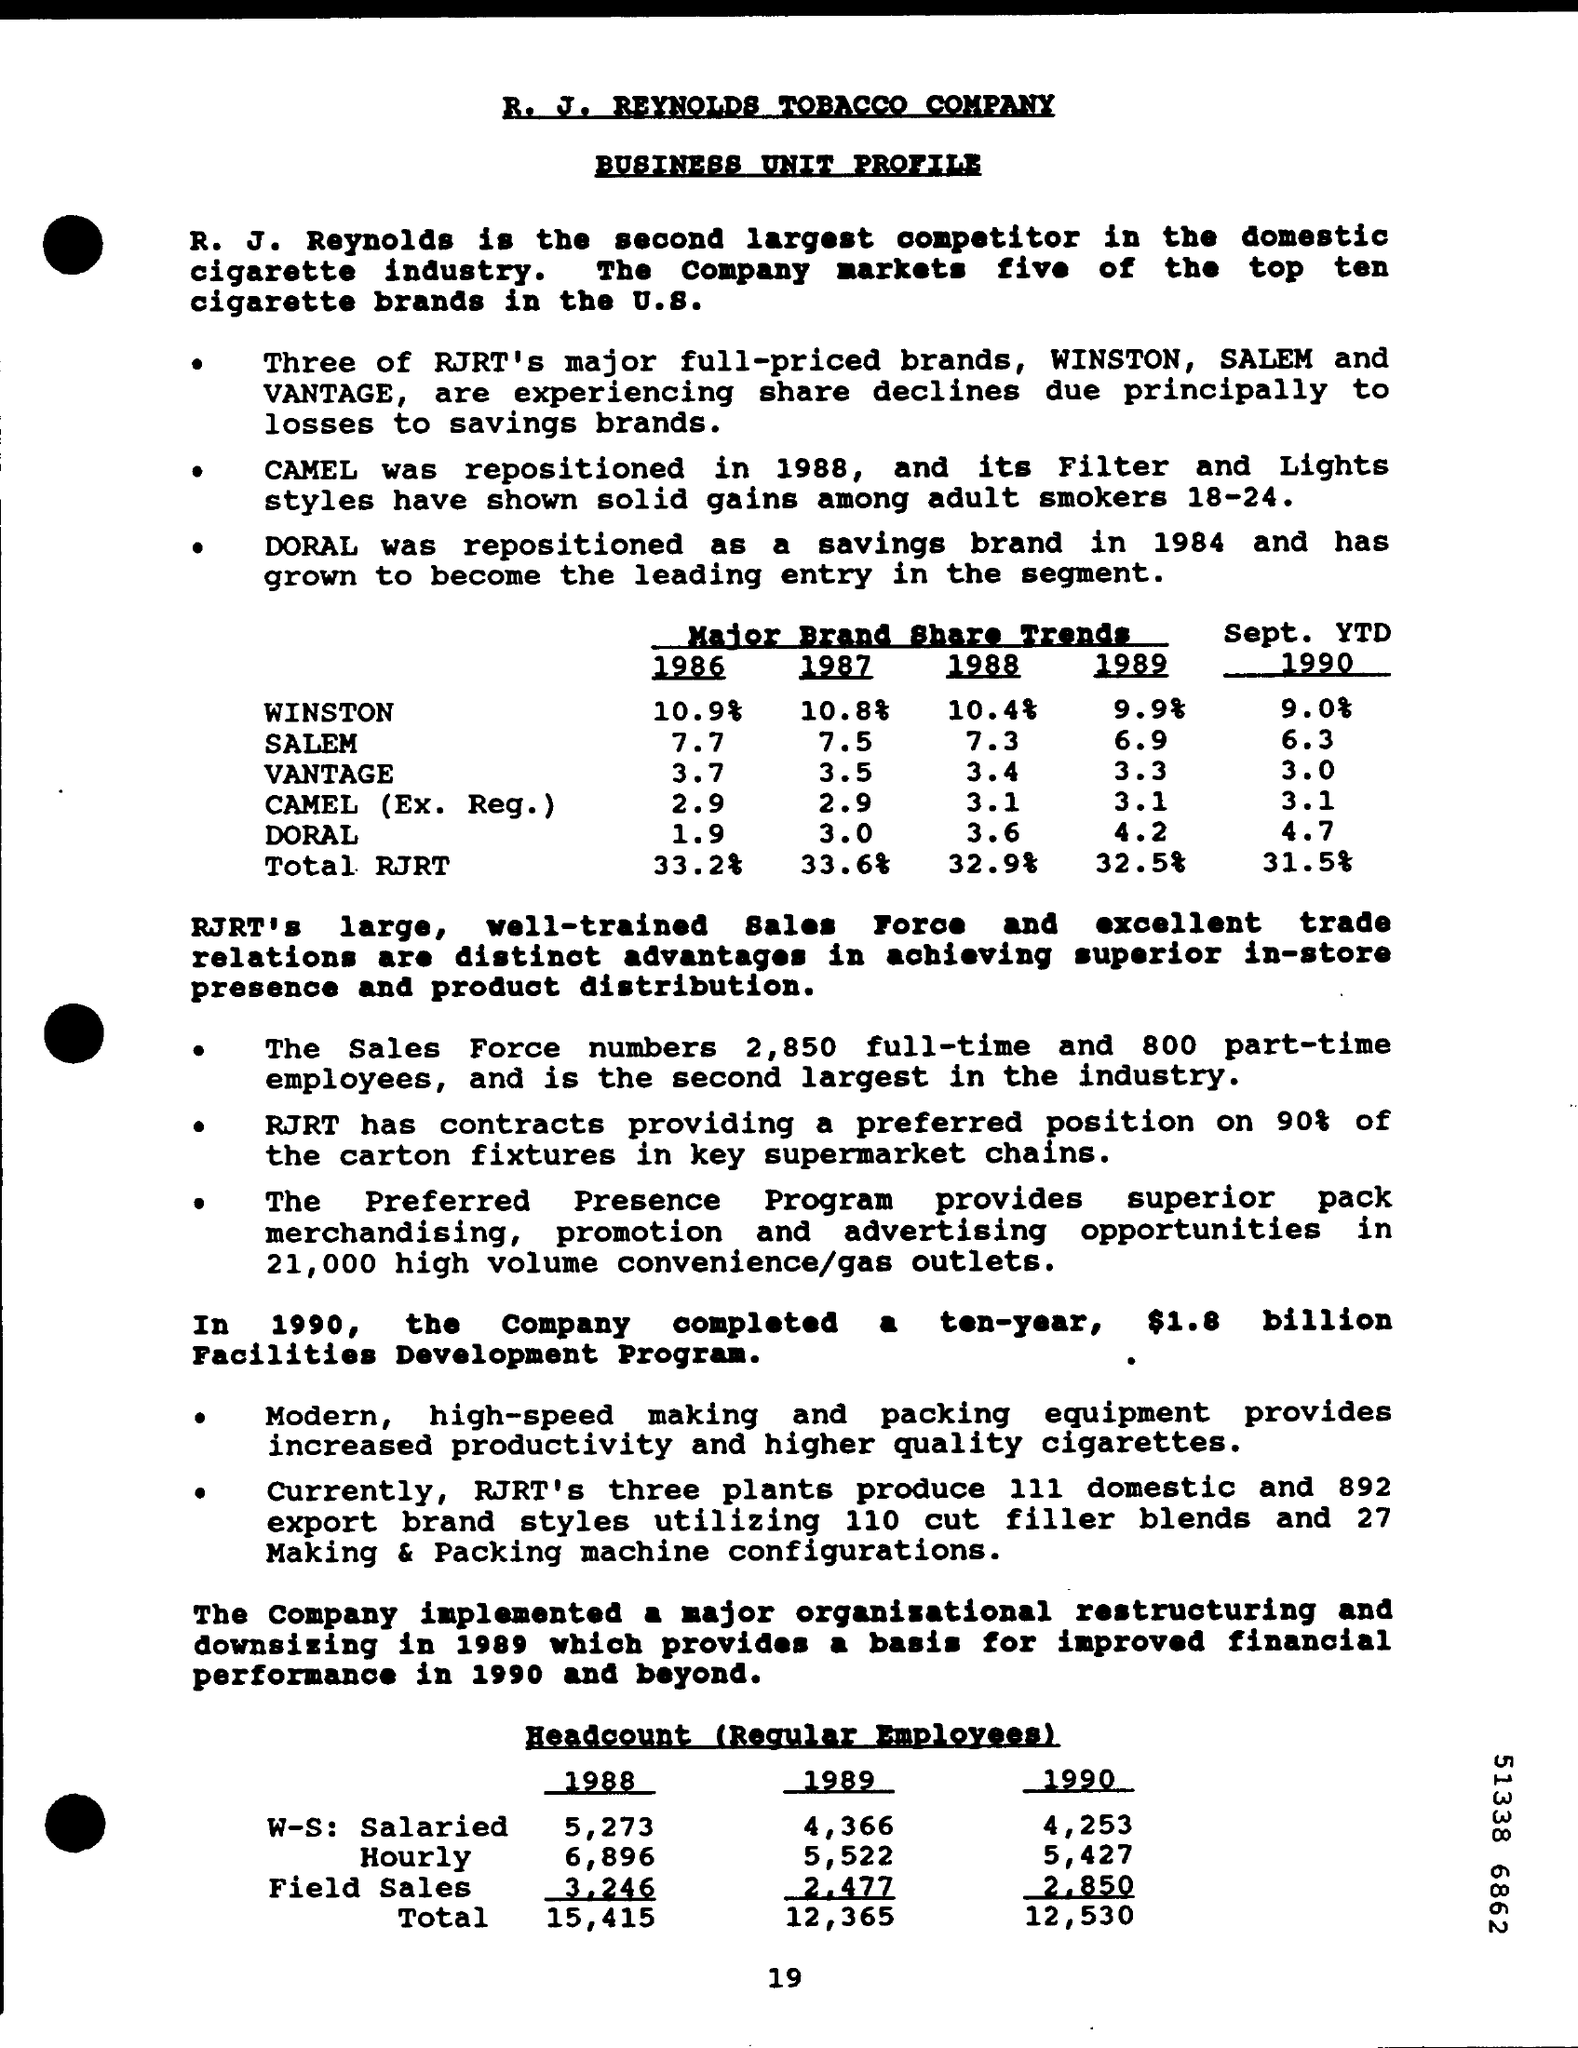Indicate a few pertinent items in this graphic. Doral, a brand belonging to RJRT, was repositioned as a savings brand in 1984. In the year 1988, the total RJRT brand share was 32.9%. The brand share percentage of WINSTON in the year 1987 was 10.8%. As of the year 1990, the total headcount of regular employees was 12,530. The total headcount of regular employees for the year 1988 was 15,415. 